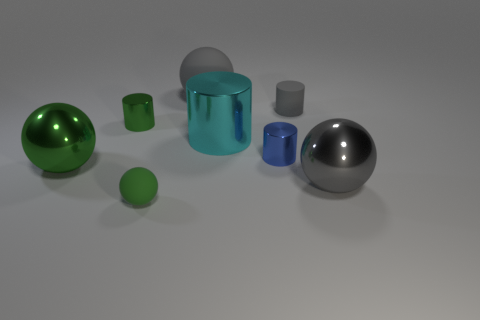Subtract all purple cubes. How many green spheres are left? 2 Subtract all gray cylinders. How many cylinders are left? 3 Subtract all tiny blue cylinders. How many cylinders are left? 3 Add 1 large green matte balls. How many objects exist? 9 Subtract all brown cylinders. Subtract all blue cubes. How many cylinders are left? 4 Subtract all green cubes. Subtract all blue shiny cylinders. How many objects are left? 7 Add 8 tiny spheres. How many tiny spheres are left? 9 Add 5 gray spheres. How many gray spheres exist? 7 Subtract 1 cyan cylinders. How many objects are left? 7 